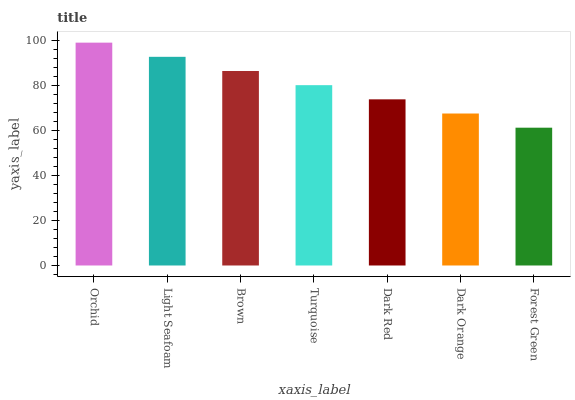Is Forest Green the minimum?
Answer yes or no. Yes. Is Orchid the maximum?
Answer yes or no. Yes. Is Light Seafoam the minimum?
Answer yes or no. No. Is Light Seafoam the maximum?
Answer yes or no. No. Is Orchid greater than Light Seafoam?
Answer yes or no. Yes. Is Light Seafoam less than Orchid?
Answer yes or no. Yes. Is Light Seafoam greater than Orchid?
Answer yes or no. No. Is Orchid less than Light Seafoam?
Answer yes or no. No. Is Turquoise the high median?
Answer yes or no. Yes. Is Turquoise the low median?
Answer yes or no. Yes. Is Forest Green the high median?
Answer yes or no. No. Is Brown the low median?
Answer yes or no. No. 